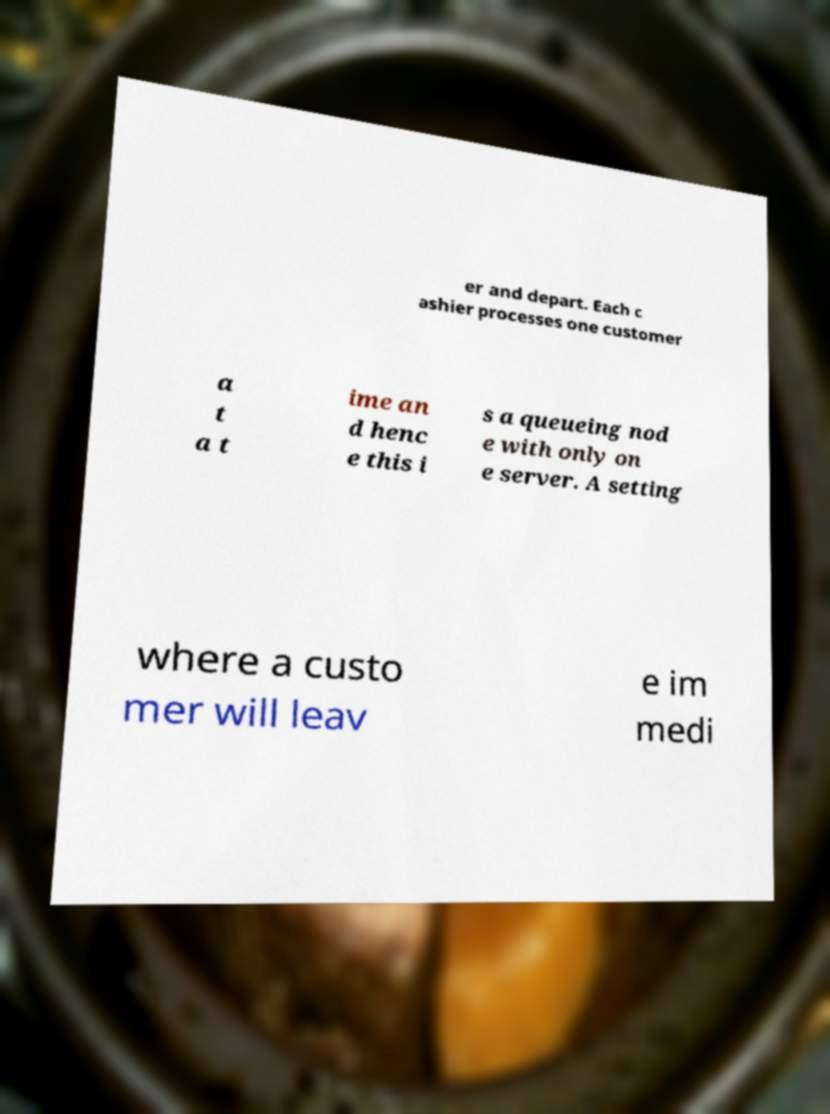Please identify and transcribe the text found in this image. er and depart. Each c ashier processes one customer a t a t ime an d henc e this i s a queueing nod e with only on e server. A setting where a custo mer will leav e im medi 